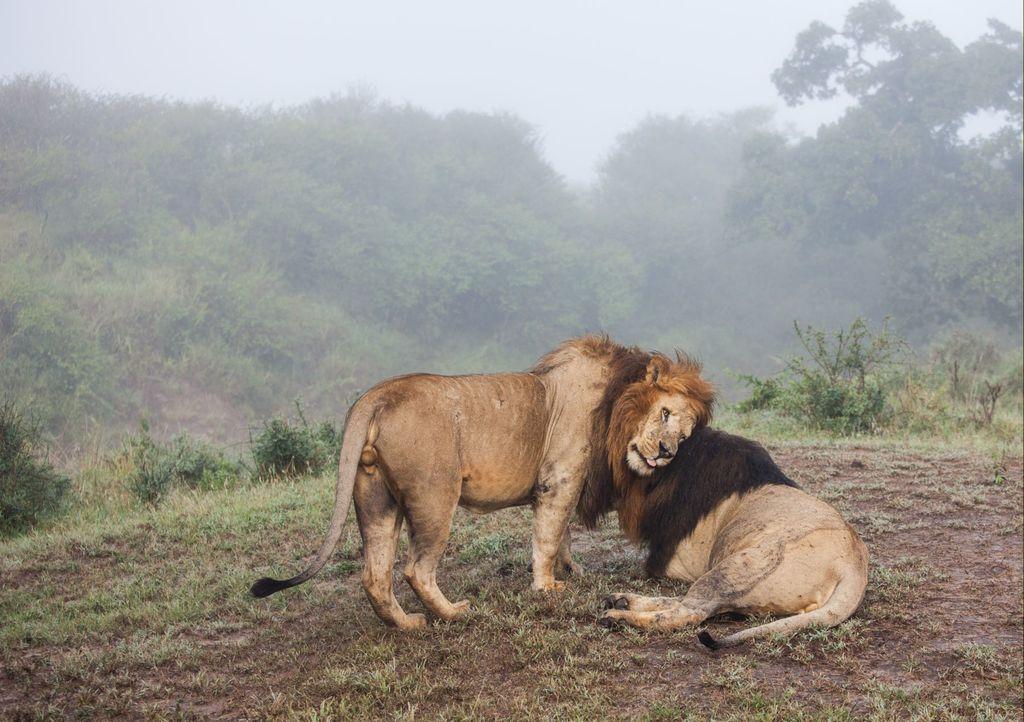Can you describe this image briefly? In this image there are two lions, one is standing and the other is sitting on the surface of the grass. In the background there are trees and a sky. 